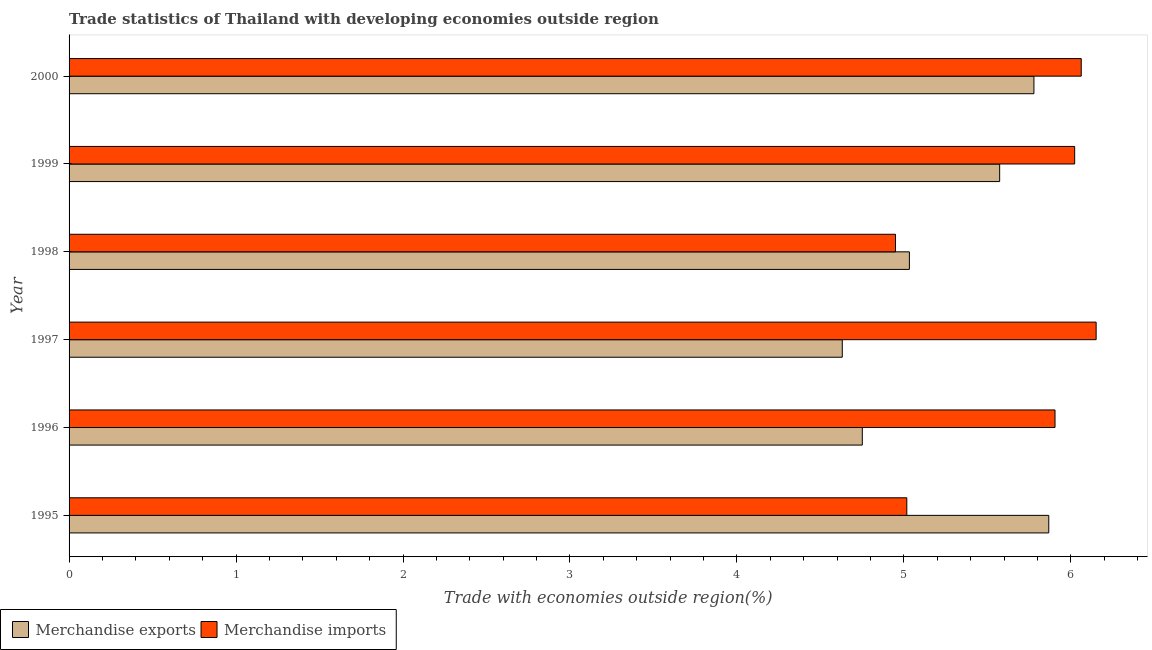How many groups of bars are there?
Give a very brief answer. 6. How many bars are there on the 3rd tick from the top?
Offer a terse response. 2. What is the label of the 3rd group of bars from the top?
Offer a very short reply. 1998. In how many cases, is the number of bars for a given year not equal to the number of legend labels?
Make the answer very short. 0. What is the merchandise imports in 1997?
Provide a succinct answer. 6.15. Across all years, what is the maximum merchandise imports?
Keep it short and to the point. 6.15. Across all years, what is the minimum merchandise imports?
Offer a terse response. 4.95. What is the total merchandise imports in the graph?
Provide a succinct answer. 34.11. What is the difference between the merchandise exports in 1997 and that in 2000?
Your answer should be compact. -1.15. What is the difference between the merchandise imports in 2000 and the merchandise exports in 1997?
Keep it short and to the point. 1.43. What is the average merchandise imports per year?
Ensure brevity in your answer.  5.68. In the year 1995, what is the difference between the merchandise imports and merchandise exports?
Your answer should be compact. -0.85. In how many years, is the merchandise imports greater than 4.4 %?
Offer a very short reply. 6. What is the ratio of the merchandise exports in 1995 to that in 1997?
Your response must be concise. 1.27. What is the difference between the highest and the second highest merchandise imports?
Ensure brevity in your answer.  0.09. What is the difference between the highest and the lowest merchandise exports?
Your response must be concise. 1.24. In how many years, is the merchandise imports greater than the average merchandise imports taken over all years?
Provide a short and direct response. 4. How many bars are there?
Your answer should be compact. 12. Are the values on the major ticks of X-axis written in scientific E-notation?
Keep it short and to the point. No. Does the graph contain any zero values?
Your answer should be very brief. No. How many legend labels are there?
Keep it short and to the point. 2. How are the legend labels stacked?
Keep it short and to the point. Horizontal. What is the title of the graph?
Ensure brevity in your answer.  Trade statistics of Thailand with developing economies outside region. Does "current US$" appear as one of the legend labels in the graph?
Offer a terse response. No. What is the label or title of the X-axis?
Your response must be concise. Trade with economies outside region(%). What is the Trade with economies outside region(%) of Merchandise exports in 1995?
Offer a very short reply. 5.87. What is the Trade with economies outside region(%) of Merchandise imports in 1995?
Your answer should be very brief. 5.02. What is the Trade with economies outside region(%) in Merchandise exports in 1996?
Keep it short and to the point. 4.75. What is the Trade with economies outside region(%) of Merchandise imports in 1996?
Provide a short and direct response. 5.91. What is the Trade with economies outside region(%) in Merchandise exports in 1997?
Your answer should be compact. 4.63. What is the Trade with economies outside region(%) of Merchandise imports in 1997?
Your answer should be compact. 6.15. What is the Trade with economies outside region(%) of Merchandise exports in 1998?
Offer a very short reply. 5.03. What is the Trade with economies outside region(%) of Merchandise imports in 1998?
Your answer should be very brief. 4.95. What is the Trade with economies outside region(%) in Merchandise exports in 1999?
Make the answer very short. 5.57. What is the Trade with economies outside region(%) in Merchandise imports in 1999?
Your answer should be very brief. 6.02. What is the Trade with economies outside region(%) of Merchandise exports in 2000?
Give a very brief answer. 5.78. What is the Trade with economies outside region(%) of Merchandise imports in 2000?
Provide a succinct answer. 6.06. Across all years, what is the maximum Trade with economies outside region(%) of Merchandise exports?
Provide a short and direct response. 5.87. Across all years, what is the maximum Trade with economies outside region(%) in Merchandise imports?
Provide a short and direct response. 6.15. Across all years, what is the minimum Trade with economies outside region(%) in Merchandise exports?
Offer a very short reply. 4.63. Across all years, what is the minimum Trade with economies outside region(%) in Merchandise imports?
Offer a terse response. 4.95. What is the total Trade with economies outside region(%) of Merchandise exports in the graph?
Keep it short and to the point. 31.64. What is the total Trade with economies outside region(%) of Merchandise imports in the graph?
Your response must be concise. 34.11. What is the difference between the Trade with economies outside region(%) in Merchandise exports in 1995 and that in 1996?
Your response must be concise. 1.12. What is the difference between the Trade with economies outside region(%) in Merchandise imports in 1995 and that in 1996?
Provide a succinct answer. -0.89. What is the difference between the Trade with economies outside region(%) in Merchandise exports in 1995 and that in 1997?
Make the answer very short. 1.24. What is the difference between the Trade with economies outside region(%) of Merchandise imports in 1995 and that in 1997?
Provide a short and direct response. -1.13. What is the difference between the Trade with economies outside region(%) in Merchandise exports in 1995 and that in 1998?
Your answer should be very brief. 0.83. What is the difference between the Trade with economies outside region(%) in Merchandise imports in 1995 and that in 1998?
Offer a terse response. 0.07. What is the difference between the Trade with economies outside region(%) in Merchandise exports in 1995 and that in 1999?
Ensure brevity in your answer.  0.29. What is the difference between the Trade with economies outside region(%) in Merchandise imports in 1995 and that in 1999?
Keep it short and to the point. -1.01. What is the difference between the Trade with economies outside region(%) in Merchandise exports in 1995 and that in 2000?
Give a very brief answer. 0.09. What is the difference between the Trade with economies outside region(%) in Merchandise imports in 1995 and that in 2000?
Give a very brief answer. -1.04. What is the difference between the Trade with economies outside region(%) of Merchandise exports in 1996 and that in 1997?
Your answer should be very brief. 0.12. What is the difference between the Trade with economies outside region(%) of Merchandise imports in 1996 and that in 1997?
Provide a succinct answer. -0.25. What is the difference between the Trade with economies outside region(%) in Merchandise exports in 1996 and that in 1998?
Give a very brief answer. -0.28. What is the difference between the Trade with economies outside region(%) in Merchandise imports in 1996 and that in 1998?
Your response must be concise. 0.96. What is the difference between the Trade with economies outside region(%) of Merchandise exports in 1996 and that in 1999?
Make the answer very short. -0.82. What is the difference between the Trade with economies outside region(%) of Merchandise imports in 1996 and that in 1999?
Your response must be concise. -0.12. What is the difference between the Trade with economies outside region(%) in Merchandise exports in 1996 and that in 2000?
Provide a succinct answer. -1.03. What is the difference between the Trade with economies outside region(%) in Merchandise imports in 1996 and that in 2000?
Make the answer very short. -0.16. What is the difference between the Trade with economies outside region(%) in Merchandise exports in 1997 and that in 1998?
Your answer should be compact. -0.4. What is the difference between the Trade with economies outside region(%) in Merchandise imports in 1997 and that in 1998?
Offer a very short reply. 1.2. What is the difference between the Trade with economies outside region(%) in Merchandise exports in 1997 and that in 1999?
Keep it short and to the point. -0.94. What is the difference between the Trade with economies outside region(%) of Merchandise imports in 1997 and that in 1999?
Keep it short and to the point. 0.13. What is the difference between the Trade with economies outside region(%) in Merchandise exports in 1997 and that in 2000?
Make the answer very short. -1.15. What is the difference between the Trade with economies outside region(%) in Merchandise imports in 1997 and that in 2000?
Give a very brief answer. 0.09. What is the difference between the Trade with economies outside region(%) of Merchandise exports in 1998 and that in 1999?
Offer a terse response. -0.54. What is the difference between the Trade with economies outside region(%) in Merchandise imports in 1998 and that in 1999?
Your answer should be compact. -1.07. What is the difference between the Trade with economies outside region(%) in Merchandise exports in 1998 and that in 2000?
Your answer should be compact. -0.75. What is the difference between the Trade with economies outside region(%) of Merchandise imports in 1998 and that in 2000?
Your answer should be very brief. -1.11. What is the difference between the Trade with economies outside region(%) of Merchandise exports in 1999 and that in 2000?
Your response must be concise. -0.21. What is the difference between the Trade with economies outside region(%) of Merchandise imports in 1999 and that in 2000?
Make the answer very short. -0.04. What is the difference between the Trade with economies outside region(%) in Merchandise exports in 1995 and the Trade with economies outside region(%) in Merchandise imports in 1996?
Provide a short and direct response. -0.04. What is the difference between the Trade with economies outside region(%) of Merchandise exports in 1995 and the Trade with economies outside region(%) of Merchandise imports in 1997?
Give a very brief answer. -0.28. What is the difference between the Trade with economies outside region(%) of Merchandise exports in 1995 and the Trade with economies outside region(%) of Merchandise imports in 1998?
Give a very brief answer. 0.92. What is the difference between the Trade with economies outside region(%) in Merchandise exports in 1995 and the Trade with economies outside region(%) in Merchandise imports in 1999?
Give a very brief answer. -0.16. What is the difference between the Trade with economies outside region(%) of Merchandise exports in 1995 and the Trade with economies outside region(%) of Merchandise imports in 2000?
Keep it short and to the point. -0.19. What is the difference between the Trade with economies outside region(%) in Merchandise exports in 1996 and the Trade with economies outside region(%) in Merchandise imports in 1997?
Give a very brief answer. -1.4. What is the difference between the Trade with economies outside region(%) of Merchandise exports in 1996 and the Trade with economies outside region(%) of Merchandise imports in 1998?
Keep it short and to the point. -0.2. What is the difference between the Trade with economies outside region(%) in Merchandise exports in 1996 and the Trade with economies outside region(%) in Merchandise imports in 1999?
Your response must be concise. -1.27. What is the difference between the Trade with economies outside region(%) in Merchandise exports in 1996 and the Trade with economies outside region(%) in Merchandise imports in 2000?
Offer a very short reply. -1.31. What is the difference between the Trade with economies outside region(%) of Merchandise exports in 1997 and the Trade with economies outside region(%) of Merchandise imports in 1998?
Ensure brevity in your answer.  -0.32. What is the difference between the Trade with economies outside region(%) of Merchandise exports in 1997 and the Trade with economies outside region(%) of Merchandise imports in 1999?
Give a very brief answer. -1.39. What is the difference between the Trade with economies outside region(%) in Merchandise exports in 1997 and the Trade with economies outside region(%) in Merchandise imports in 2000?
Your response must be concise. -1.43. What is the difference between the Trade with economies outside region(%) of Merchandise exports in 1998 and the Trade with economies outside region(%) of Merchandise imports in 1999?
Keep it short and to the point. -0.99. What is the difference between the Trade with economies outside region(%) in Merchandise exports in 1998 and the Trade with economies outside region(%) in Merchandise imports in 2000?
Ensure brevity in your answer.  -1.03. What is the difference between the Trade with economies outside region(%) in Merchandise exports in 1999 and the Trade with economies outside region(%) in Merchandise imports in 2000?
Your answer should be compact. -0.49. What is the average Trade with economies outside region(%) in Merchandise exports per year?
Ensure brevity in your answer.  5.27. What is the average Trade with economies outside region(%) of Merchandise imports per year?
Ensure brevity in your answer.  5.68. In the year 1995, what is the difference between the Trade with economies outside region(%) of Merchandise exports and Trade with economies outside region(%) of Merchandise imports?
Your response must be concise. 0.85. In the year 1996, what is the difference between the Trade with economies outside region(%) in Merchandise exports and Trade with economies outside region(%) in Merchandise imports?
Ensure brevity in your answer.  -1.15. In the year 1997, what is the difference between the Trade with economies outside region(%) of Merchandise exports and Trade with economies outside region(%) of Merchandise imports?
Make the answer very short. -1.52. In the year 1998, what is the difference between the Trade with economies outside region(%) in Merchandise exports and Trade with economies outside region(%) in Merchandise imports?
Give a very brief answer. 0.08. In the year 1999, what is the difference between the Trade with economies outside region(%) in Merchandise exports and Trade with economies outside region(%) in Merchandise imports?
Provide a short and direct response. -0.45. In the year 2000, what is the difference between the Trade with economies outside region(%) in Merchandise exports and Trade with economies outside region(%) in Merchandise imports?
Offer a very short reply. -0.28. What is the ratio of the Trade with economies outside region(%) in Merchandise exports in 1995 to that in 1996?
Provide a succinct answer. 1.24. What is the ratio of the Trade with economies outside region(%) of Merchandise imports in 1995 to that in 1996?
Give a very brief answer. 0.85. What is the ratio of the Trade with economies outside region(%) of Merchandise exports in 1995 to that in 1997?
Your response must be concise. 1.27. What is the ratio of the Trade with economies outside region(%) of Merchandise imports in 1995 to that in 1997?
Keep it short and to the point. 0.82. What is the ratio of the Trade with economies outside region(%) in Merchandise exports in 1995 to that in 1998?
Provide a succinct answer. 1.17. What is the ratio of the Trade with economies outside region(%) in Merchandise imports in 1995 to that in 1998?
Your answer should be very brief. 1.01. What is the ratio of the Trade with economies outside region(%) of Merchandise exports in 1995 to that in 1999?
Offer a terse response. 1.05. What is the ratio of the Trade with economies outside region(%) in Merchandise imports in 1995 to that in 1999?
Offer a terse response. 0.83. What is the ratio of the Trade with economies outside region(%) of Merchandise exports in 1995 to that in 2000?
Your response must be concise. 1.02. What is the ratio of the Trade with economies outside region(%) of Merchandise imports in 1995 to that in 2000?
Provide a succinct answer. 0.83. What is the ratio of the Trade with economies outside region(%) in Merchandise exports in 1996 to that in 1997?
Offer a very short reply. 1.03. What is the ratio of the Trade with economies outside region(%) in Merchandise exports in 1996 to that in 1998?
Provide a succinct answer. 0.94. What is the ratio of the Trade with economies outside region(%) of Merchandise imports in 1996 to that in 1998?
Provide a succinct answer. 1.19. What is the ratio of the Trade with economies outside region(%) in Merchandise exports in 1996 to that in 1999?
Ensure brevity in your answer.  0.85. What is the ratio of the Trade with economies outside region(%) of Merchandise imports in 1996 to that in 1999?
Provide a succinct answer. 0.98. What is the ratio of the Trade with economies outside region(%) of Merchandise exports in 1996 to that in 2000?
Make the answer very short. 0.82. What is the ratio of the Trade with economies outside region(%) of Merchandise imports in 1996 to that in 2000?
Offer a terse response. 0.97. What is the ratio of the Trade with economies outside region(%) in Merchandise exports in 1997 to that in 1998?
Offer a terse response. 0.92. What is the ratio of the Trade with economies outside region(%) in Merchandise imports in 1997 to that in 1998?
Offer a very short reply. 1.24. What is the ratio of the Trade with economies outside region(%) in Merchandise exports in 1997 to that in 1999?
Ensure brevity in your answer.  0.83. What is the ratio of the Trade with economies outside region(%) of Merchandise imports in 1997 to that in 1999?
Give a very brief answer. 1.02. What is the ratio of the Trade with economies outside region(%) of Merchandise exports in 1997 to that in 2000?
Keep it short and to the point. 0.8. What is the ratio of the Trade with economies outside region(%) of Merchandise imports in 1997 to that in 2000?
Your answer should be compact. 1.01. What is the ratio of the Trade with economies outside region(%) of Merchandise exports in 1998 to that in 1999?
Keep it short and to the point. 0.9. What is the ratio of the Trade with economies outside region(%) of Merchandise imports in 1998 to that in 1999?
Give a very brief answer. 0.82. What is the ratio of the Trade with economies outside region(%) in Merchandise exports in 1998 to that in 2000?
Keep it short and to the point. 0.87. What is the ratio of the Trade with economies outside region(%) in Merchandise imports in 1998 to that in 2000?
Give a very brief answer. 0.82. What is the ratio of the Trade with economies outside region(%) of Merchandise exports in 1999 to that in 2000?
Provide a short and direct response. 0.96. What is the ratio of the Trade with economies outside region(%) in Merchandise imports in 1999 to that in 2000?
Ensure brevity in your answer.  0.99. What is the difference between the highest and the second highest Trade with economies outside region(%) of Merchandise exports?
Your answer should be very brief. 0.09. What is the difference between the highest and the second highest Trade with economies outside region(%) in Merchandise imports?
Your answer should be very brief. 0.09. What is the difference between the highest and the lowest Trade with economies outside region(%) of Merchandise exports?
Make the answer very short. 1.24. What is the difference between the highest and the lowest Trade with economies outside region(%) in Merchandise imports?
Your answer should be very brief. 1.2. 